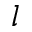Convert formula to latex. <formula><loc_0><loc_0><loc_500><loc_500>l</formula> 